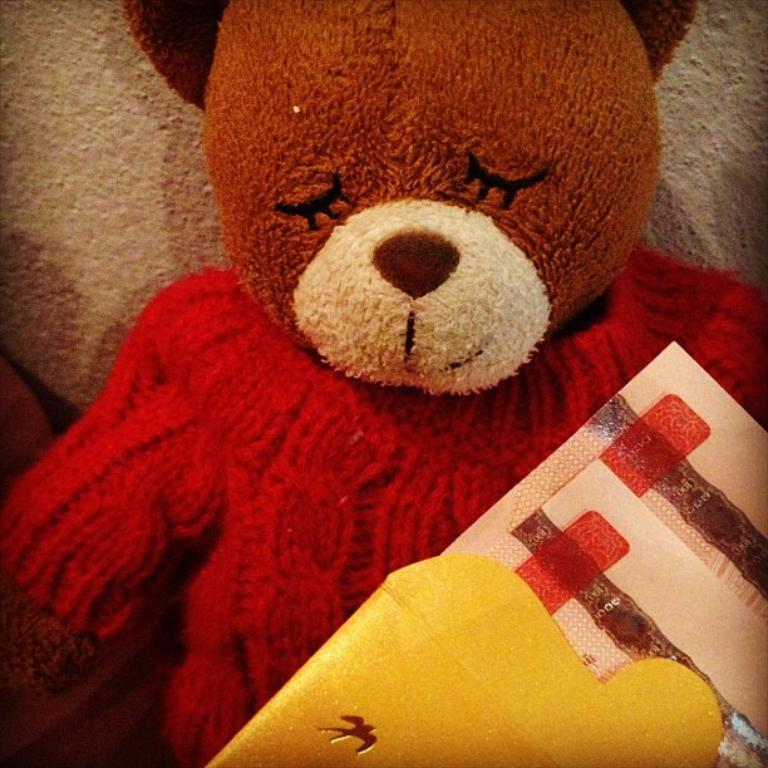What type of toy is present in the image? There is a teddy bear in the image. Can you describe the positioning of the teddy bear in relation to other objects? There is an object in front of the teddy bear. What reason does the teddy bear have for attending school in the image? There is no indication in the image that the teddy bear is attending school or has any reason for doing so. 